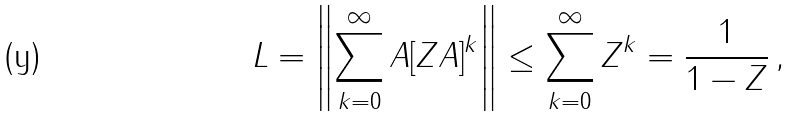<formula> <loc_0><loc_0><loc_500><loc_500>\| L \| = \left \| \sum _ { k = 0 } ^ { \infty } A [ Z A ] ^ { k } \right \| \leq \sum _ { k = 0 } ^ { \infty } \| Z \| ^ { k } = \frac { 1 } { 1 - \| Z \| } \, ,</formula> 